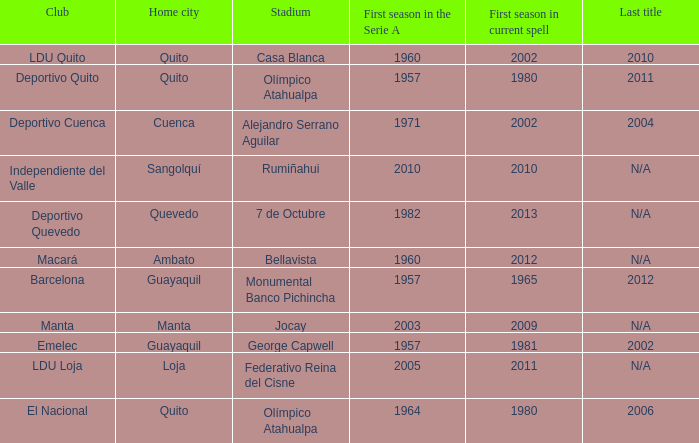Name the last title for 2012 N/A. 